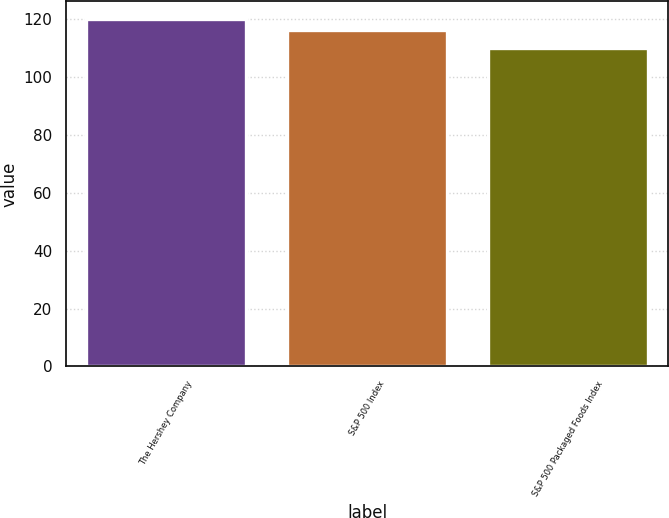Convert chart. <chart><loc_0><loc_0><loc_500><loc_500><bar_chart><fcel>The Hershey Company<fcel>S&P 500 Index<fcel>S&P 500 Packaged Foods Index<nl><fcel>120<fcel>116<fcel>110<nl></chart> 